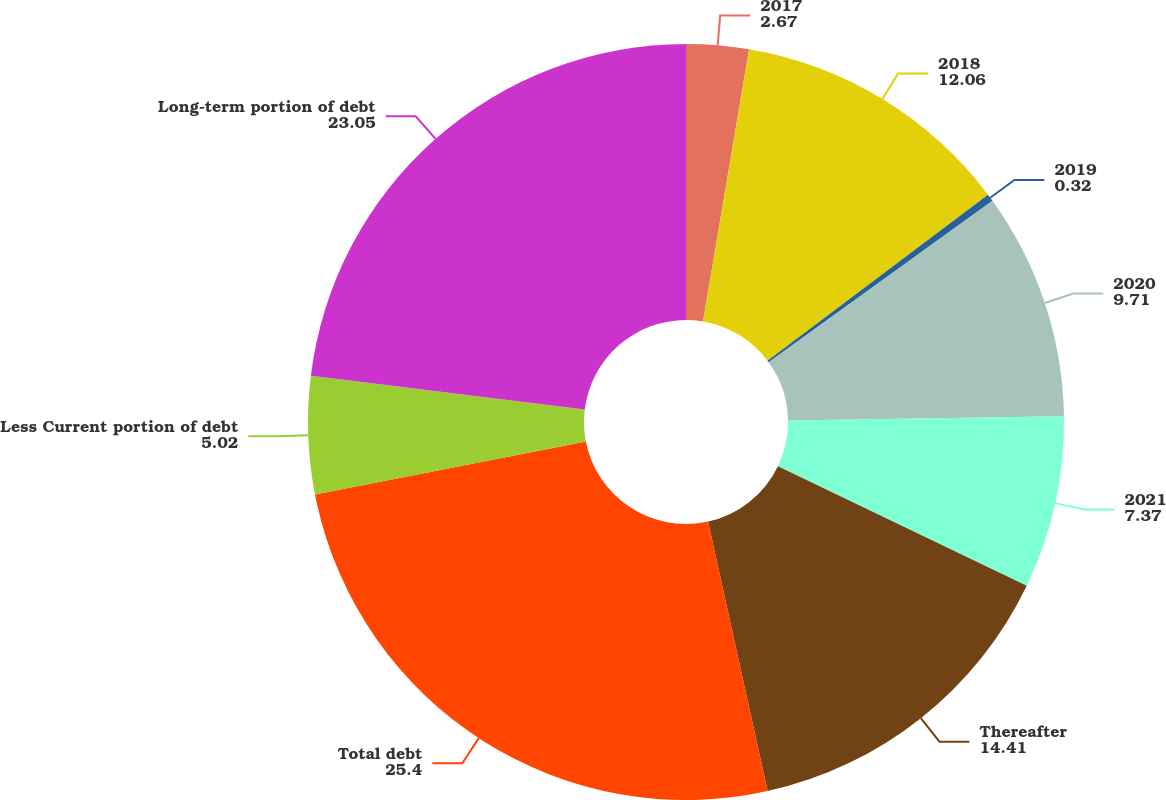Convert chart to OTSL. <chart><loc_0><loc_0><loc_500><loc_500><pie_chart><fcel>2017<fcel>2018<fcel>2019<fcel>2020<fcel>2021<fcel>Thereafter<fcel>Total debt<fcel>Less Current portion of debt<fcel>Long-term portion of debt<nl><fcel>2.67%<fcel>12.06%<fcel>0.32%<fcel>9.71%<fcel>7.37%<fcel>14.41%<fcel>25.4%<fcel>5.02%<fcel>23.05%<nl></chart> 